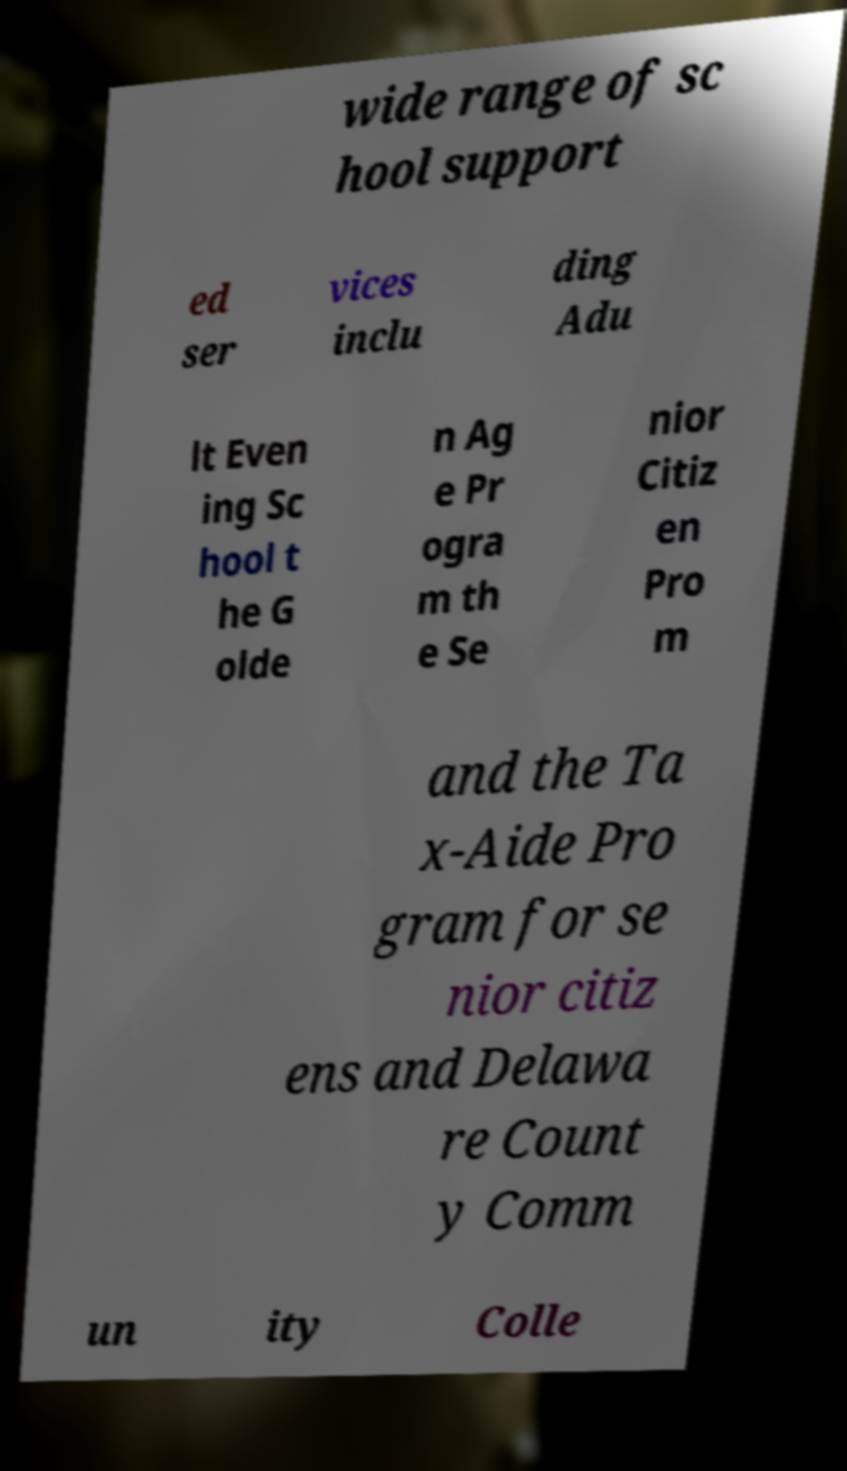For documentation purposes, I need the text within this image transcribed. Could you provide that? wide range of sc hool support ed ser vices inclu ding Adu lt Even ing Sc hool t he G olde n Ag e Pr ogra m th e Se nior Citiz en Pro m and the Ta x-Aide Pro gram for se nior citiz ens and Delawa re Count y Comm un ity Colle 